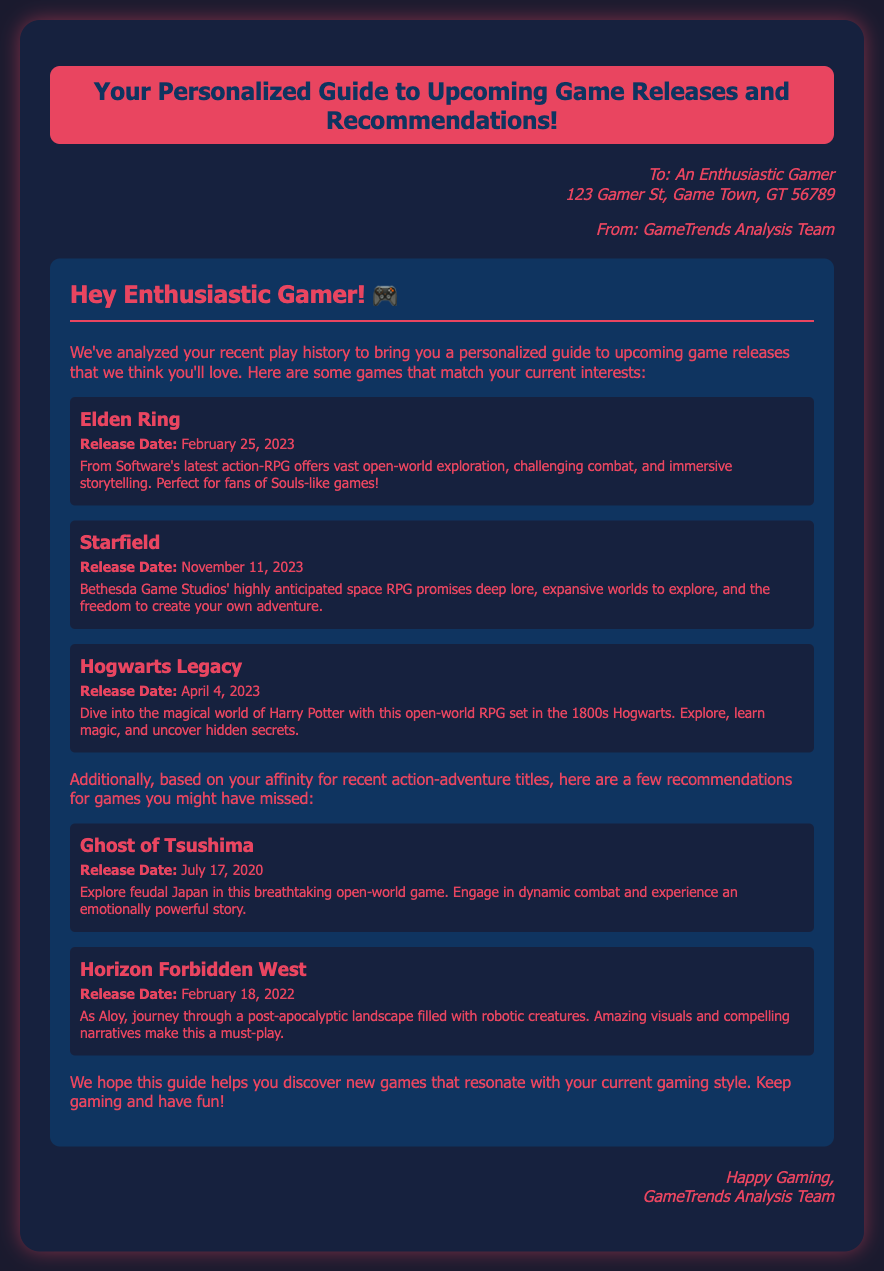What is the title of the document? The title is presented prominently at the top of the document, introducing the content.
Answer: Your Personalized Guide to Upcoming Game Releases and Recommendations! What is the release date of Elden Ring? The document provides specific release dates for each game mentioned, including Elden Ring.
Answer: February 25, 2023 Who is the senders of the envelope? The sender's information is clearly stated at the bottom of the address section.
Answer: GameTrends Analysis Team What genre does Hogwarts Legacy belong to? The genre can be inferred from the description surrounding its gameplay elements and setting.
Answer: Open-world RPG Which game is recommended for players interested in action-adventure titles? Multiple games are recommended for their appeal to a specific genre, including this one.
Answer: Ghost of Tsushima How many games are listed as upcoming releases? The total number of upcoming game releases can be counted directly in the content section.
Answer: Three What character do you play as in Horizon Forbidden West? This information is found in the game description and relates to the protagonist's identity.
Answer: Aloy When is Starfield set to be released? The release date is explicitly mentioned in the details provided for the game.
Answer: November 11, 2023 